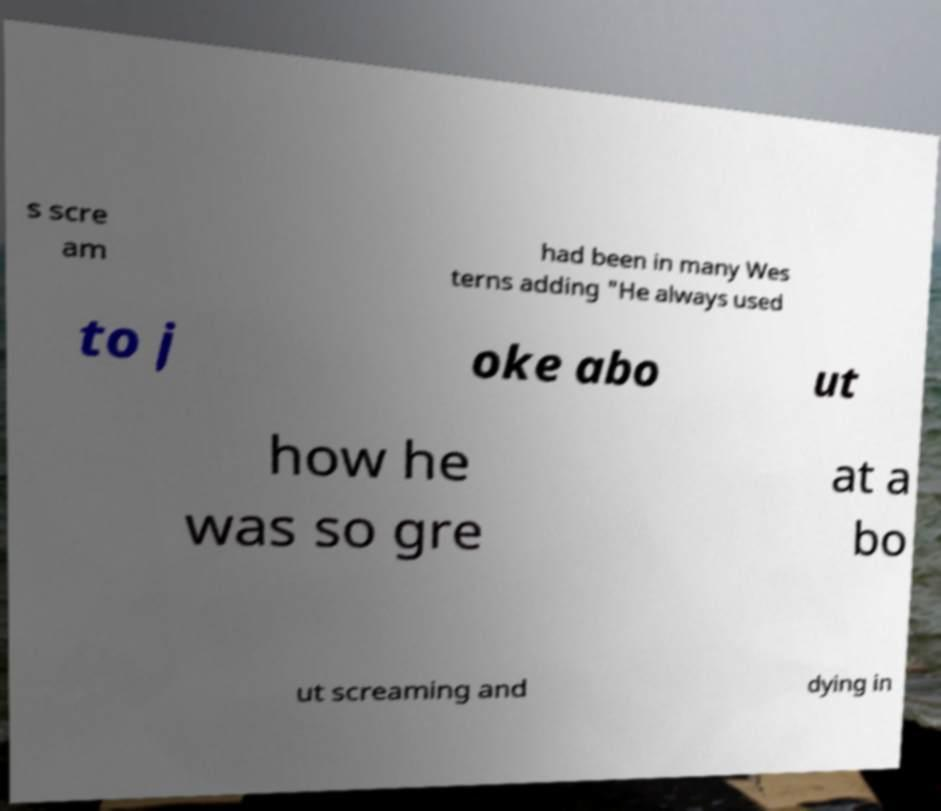Can you accurately transcribe the text from the provided image for me? s scre am had been in many Wes terns adding "He always used to j oke abo ut how he was so gre at a bo ut screaming and dying in 